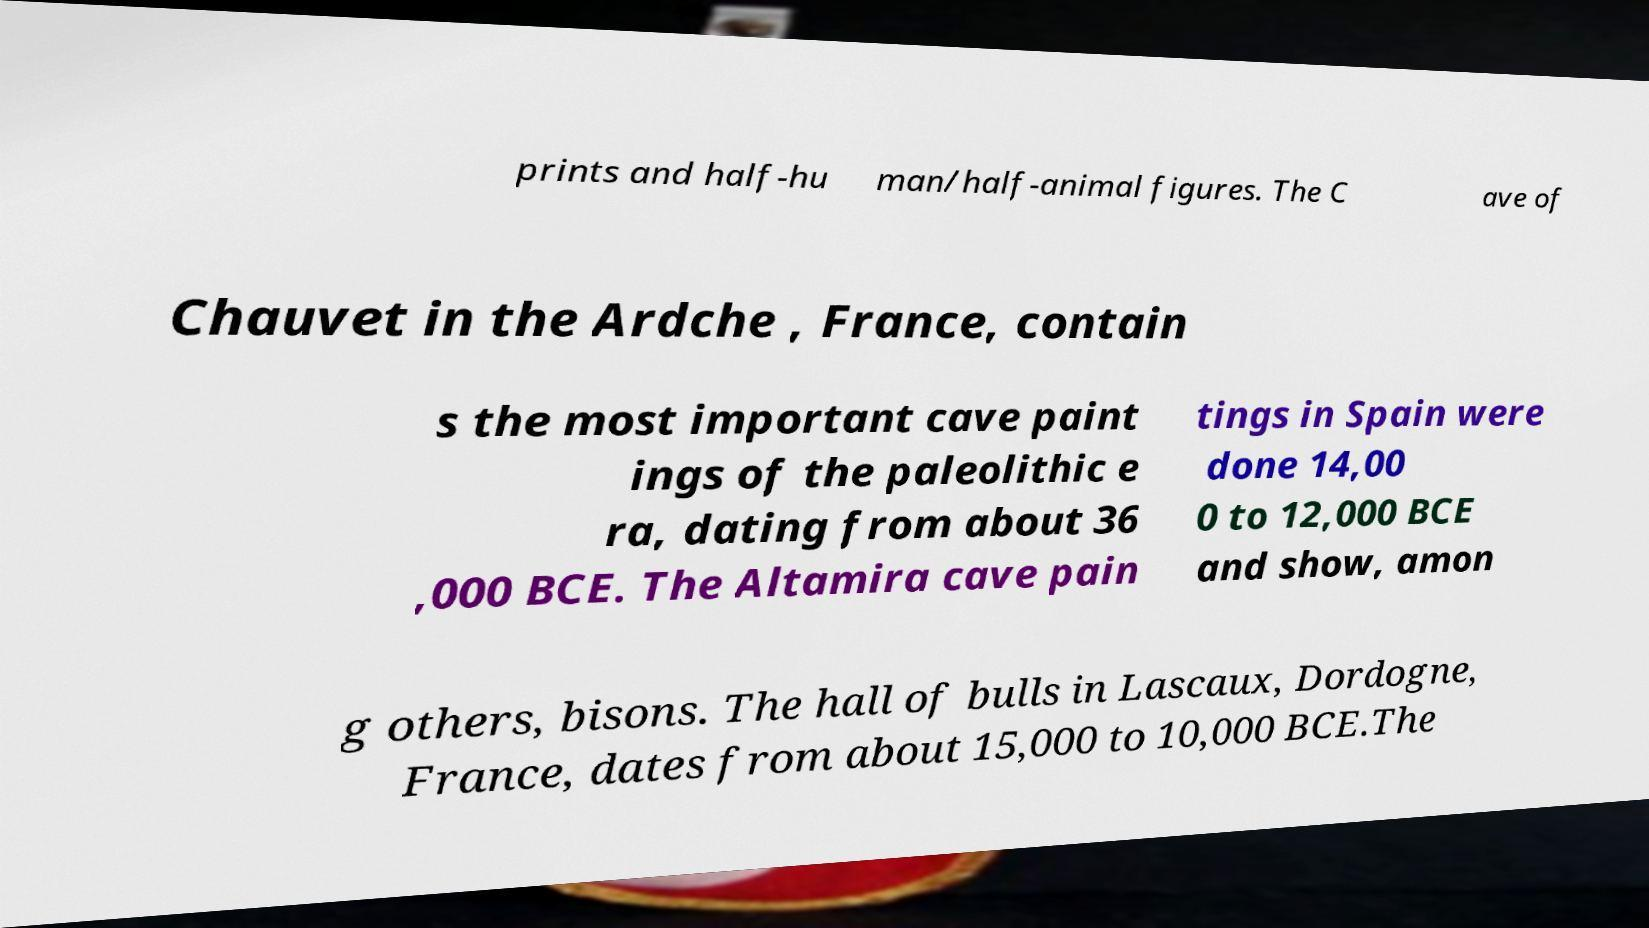Please identify and transcribe the text found in this image. prints and half-hu man/half-animal figures. The C ave of Chauvet in the Ardche , France, contain s the most important cave paint ings of the paleolithic e ra, dating from about 36 ,000 BCE. The Altamira cave pain tings in Spain were done 14,00 0 to 12,000 BCE and show, amon g others, bisons. The hall of bulls in Lascaux, Dordogne, France, dates from about 15,000 to 10,000 BCE.The 